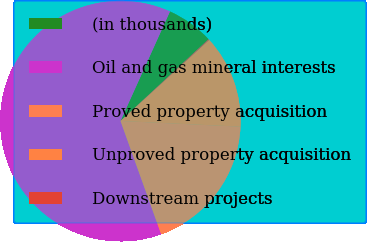<chart> <loc_0><loc_0><loc_500><loc_500><pie_chart><fcel>(in thousands)<fcel>Oil and gas mineral interests<fcel>Proved property acquisition<fcel>Unproved property acquisition<fcel>Downstream projects<nl><fcel>6.33%<fcel>62.24%<fcel>18.76%<fcel>12.55%<fcel>0.12%<nl></chart> 